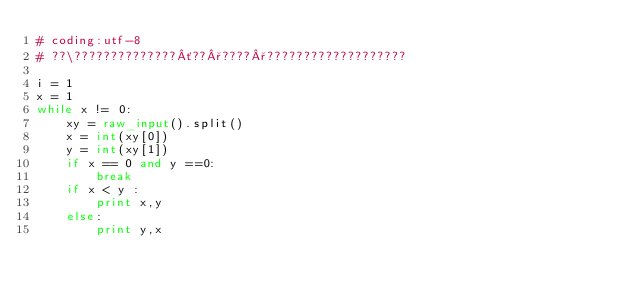Convert code to text. <code><loc_0><loc_0><loc_500><loc_500><_Python_># coding:utf-8
# ??\??????????????´??°????°???????????????????

i = 1
x = 1
while x != 0:
    xy = raw_input().split()
    x = int(xy[0])
    y = int(xy[1])
    if x == 0 and y ==0:
        break
    if x < y :
        print x,y
    else:
        print y,x</code> 